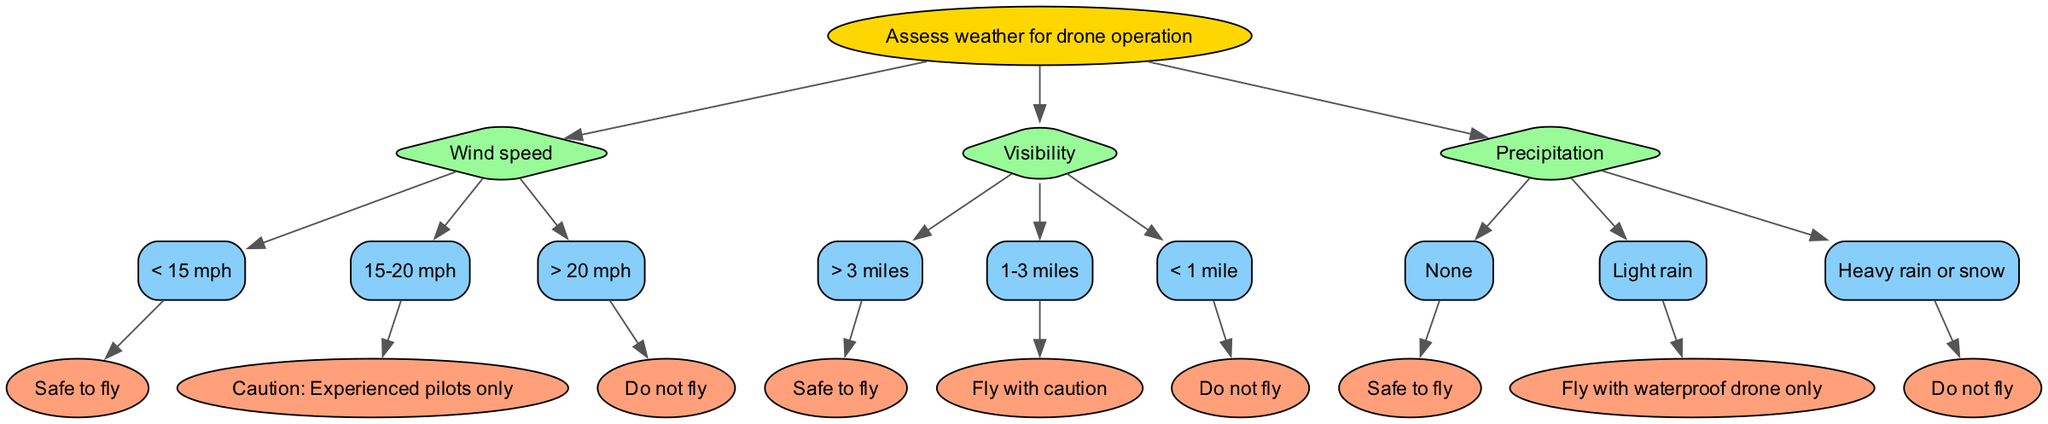What are the conditions assessed in the diagram? The diagram assesses three conditions for drone operation: Wind speed, Visibility, and Precipitation. Each condition has branching options leading to different outcomes.
Answer: Wind speed, Visibility, Precipitation What is the result when the wind speed is greater than 20 mph? According to the diagram, if the wind speed exceeds 20 mph, it leads to a terminal node stating "Do not fly." This means it is not safe to operate the drone under those conditions.
Answer: Do not fly How many safety outcomes are provided for wind speed? The diagram includes three different outcomes for wind speed: "Safe to fly," "Caution: Experienced pilots only," and "Do not fly." Therefore, the total number of outcomes associated with wind speed is three.
Answer: 3 If visibility is between 1 and 3 miles, what should a pilot do? The diagram indicates that if visibility is in the range of 1-3 miles, the recommendation is to "Fly with caution." This suggests that while flying is permissible, extra care should be taken.
Answer: Fly with caution What do you do if there is heavy rain or snow? The diagram specifies that in the case of heavy rain or snow, the instruction is "Do not fly." This indicates that such weather conditions are deemed unsafe for drone operation.
Answer: Do not fly What conditions lead to a "Safe to fly" outcome? According to the diagram, a "Safe to fly" outcome can occur if the wind speed is less than 15 mph, visibility is greater than 3 miles, or there is no precipitation. Each of these conditions allows for safe operation.
Answer: Wind speed < 15 mph, Visibility > 3 miles, No precipitation What is the relationship between wind speed and caution? The diagram establishes that if the wind speed is between 15-20 mph, it leads to the outcome "Caution: Experienced pilots only." This indicates that moderate wind speed warrants caution for less experienced pilots.
Answer: Caution: Experienced pilots only How many options are there for the precipitation condition? The diagram presents three options regarding precipitation: "None," "Light rain," and "Heavy rain or snow." Thus, the total number of options associated with precipitation is three.
Answer: 3 